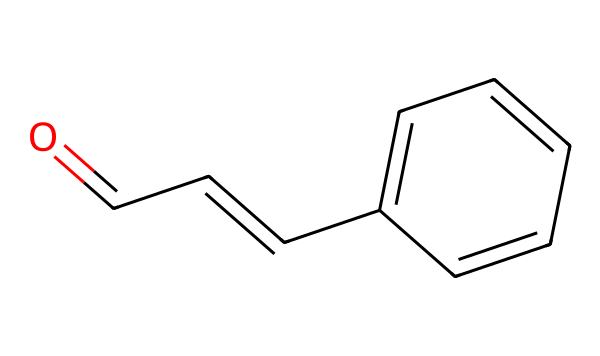What is the molecular formula of cinnamaldehyde? To deduce the molecular formula, we count the carbon (C), hydrogen (H), and oxygen (O) atoms present in the SMILES. There are 9 carbon atoms, 8 hydrogen atoms, and 1 oxygen atom, which gives the formula C9H8O.
Answer: C9H8O How many double bonds are present in cinnamaldehyde? In the structure represented by the SMILES, there are two double bonds: one in the aldehyde group (C=O) and another in the carbon chain (C=C). Therefore, the total number of double bonds is 2.
Answer: 2 What functional group is indicated by the structure of cinnamaldehyde? The structure includes a carbonyl group (C=O) at the end of the carbon chain, indicative of an aldehyde. The presence of this group confirms it as an aldehyde functional group.
Answer: aldehyde Is cinnamaldehyde an aromatic compound? Yes, the presence of a benzene ring in the structure, as indicated by the alternating double bonds, confirms that cinnamaldehyde is an aromatic compound.
Answer: Yes How many carbon atoms are in the benzene ring of cinnamaldehyde? The benzene ring consists of six carbon atoms connected in a cyclic arrangement. The structure reveals that there are indeed six carbons in the ring.
Answer: 6 In which position is the aldehyde group located on the carbon chain of cinnamaldehyde? The aldehyde group (C=O) is located at the first carbon position of the linear chain, attached to the carbon that is adjacent to the aromatic ring. Thus, its position is often referred to as the 1-position.
Answer: 1-position Does cinnamaldehyde possess any chiral centers? Chiral centers are defined as carbon atoms that have four different substituents. Upon examining the structure, there are no such carbons in cinnamaldehyde, indicating there are no chiral centers.
Answer: No 